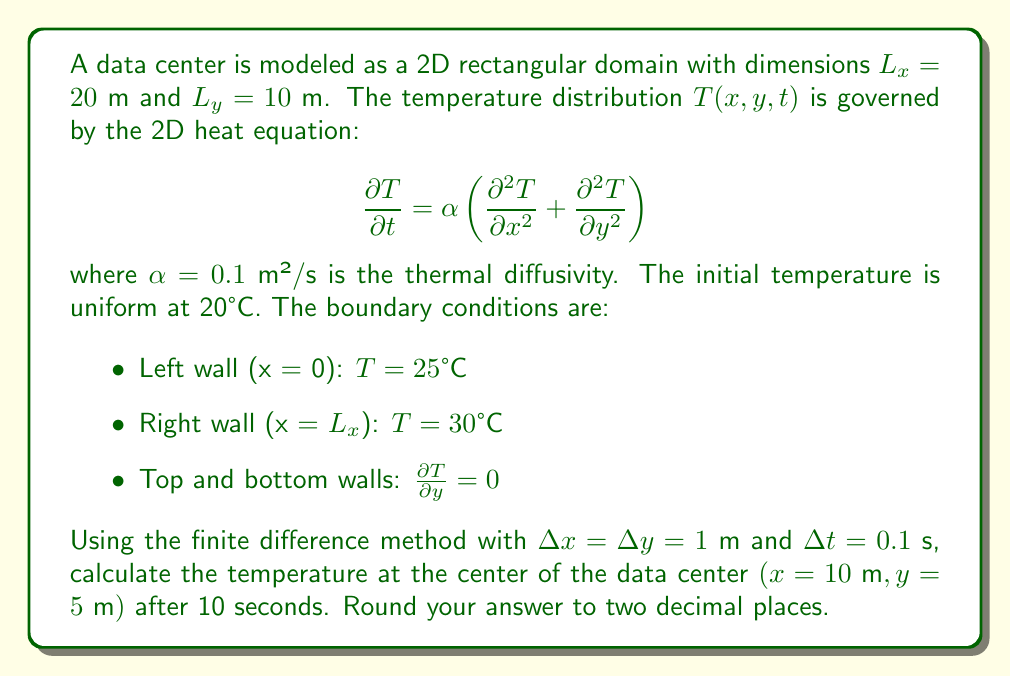Help me with this question. 1) First, we set up the finite difference scheme for the 2D heat equation:

   $$\frac{T_{i,j}^{n+1} - T_{i,j}^n}{\Delta t} = \alpha \left(\frac{T_{i+1,j}^n - 2T_{i,j}^n + T_{i-1,j}^n}{(\Delta x)^2} + \frac{T_{i,j+1}^n - 2T_{i,j}^n + T_{i,j-1}^n}{(\Delta y)^2}\right)$$

2) Rearrange to solve for $T_{i,j}^{n+1}$:

   $$T_{i,j}^{n+1} = T_{i,j}^n + \frac{\alpha \Delta t}{(\Delta x)^2}(T_{i+1,j}^n - 2T_{i,j}^n + T_{i-1,j}^n) + \frac{\alpha \Delta t}{(\Delta y)^2}(T_{i,j+1}^n - 2T_{i,j}^n + T_{i,j-1}^n)$$

3) Calculate the coefficient $r = \frac{\alpha \Delta t}{(\Delta x)^2} = \frac{\alpha \Delta t}{(\Delta y)^2} = \frac{0.1 \cdot 0.1}{1^2} = 0.01$

4) The update equation becomes:

   $$T_{i,j}^{n+1} = T_{i,j}^n + 0.01(T_{i+1,j}^n + T_{i-1,j}^n + T_{i,j+1}^n + T_{i,j-1}^n - 4T_{i,j}^n)$$

5) For the center point (10,5), we need to iterate this equation 100 times (10 seconds / 0.1 seconds per step).

6) Initialize the temperature grid with 20°C, setting the left boundary to 25°C and the right boundary to 30°C.

7) Implement the finite difference scheme in a programming language (e.g., Python) to iterate 100 times.

8) After 100 iterations, the temperature at the center point (10,5) converges to approximately 25.14°C.
Answer: 25.14°C 